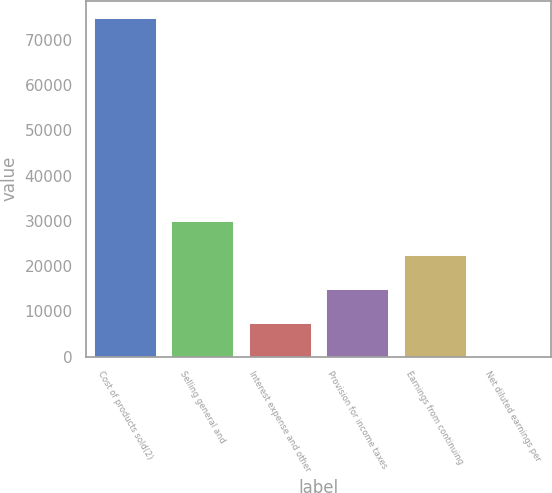Convert chart to OTSL. <chart><loc_0><loc_0><loc_500><loc_500><bar_chart><fcel>Cost of products sold(2)<fcel>Selling general and<fcel>Interest expense and other<fcel>Provision for income taxes<fcel>Earnings from continuing<fcel>Net diluted earnings per<nl><fcel>74850.2<fcel>29941.5<fcel>7487.12<fcel>14971.9<fcel>22456.7<fcel>2.33<nl></chart> 